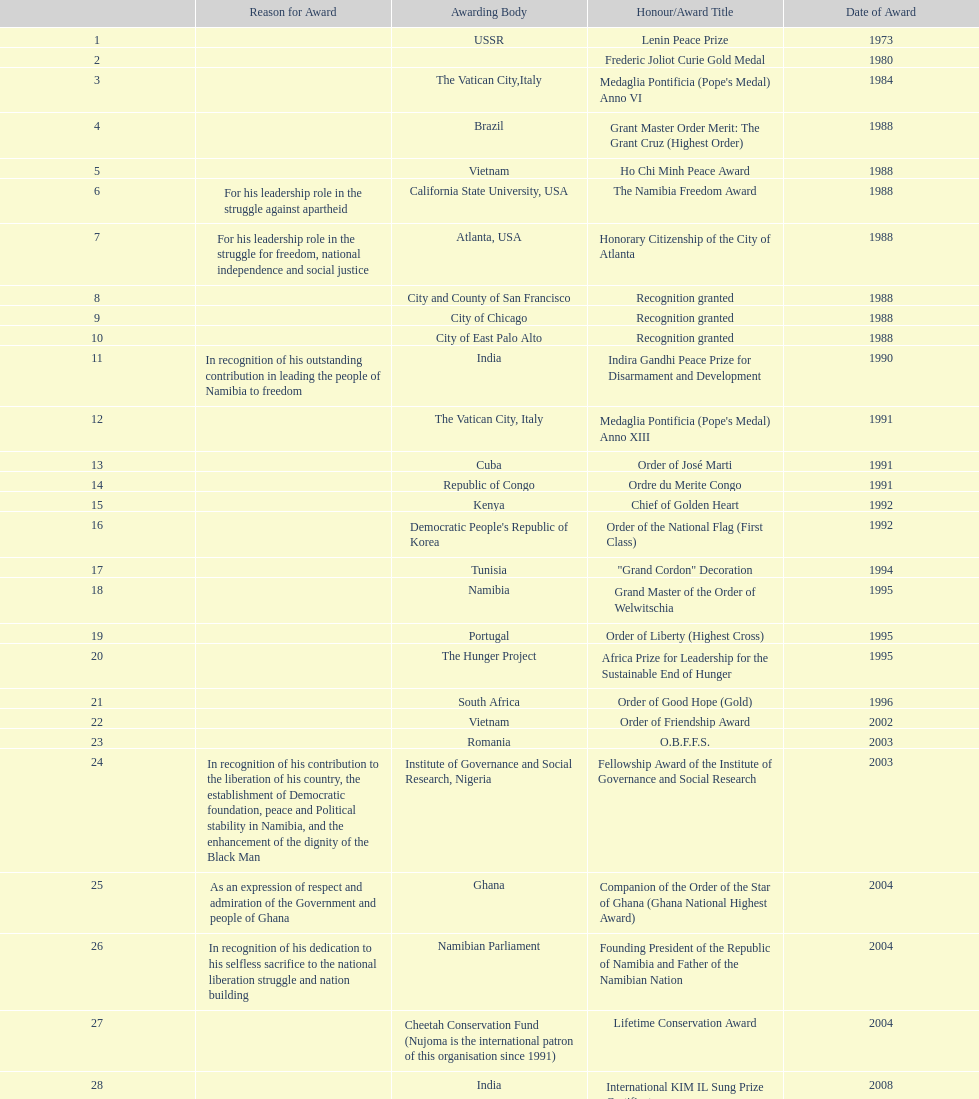What was the last award that nujoma won? Sir Seretse Khama SADC Meda. 